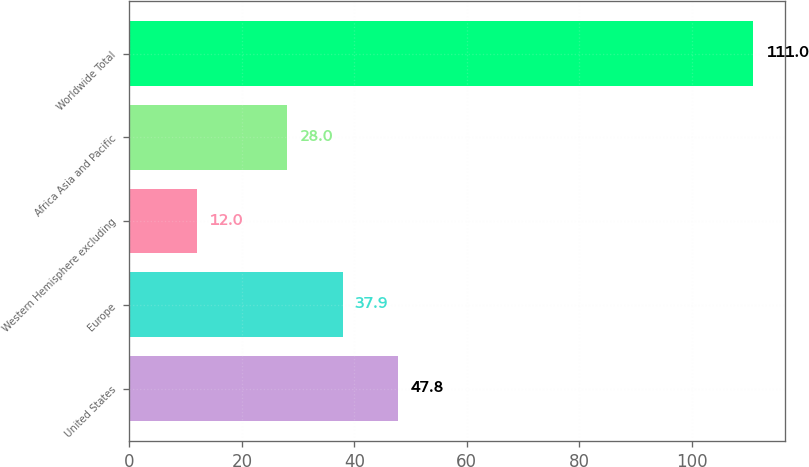Convert chart to OTSL. <chart><loc_0><loc_0><loc_500><loc_500><bar_chart><fcel>United States<fcel>Europe<fcel>Western Hemisphere excluding<fcel>Africa Asia and Pacific<fcel>Worldwide Total<nl><fcel>47.8<fcel>37.9<fcel>12<fcel>28<fcel>111<nl></chart> 